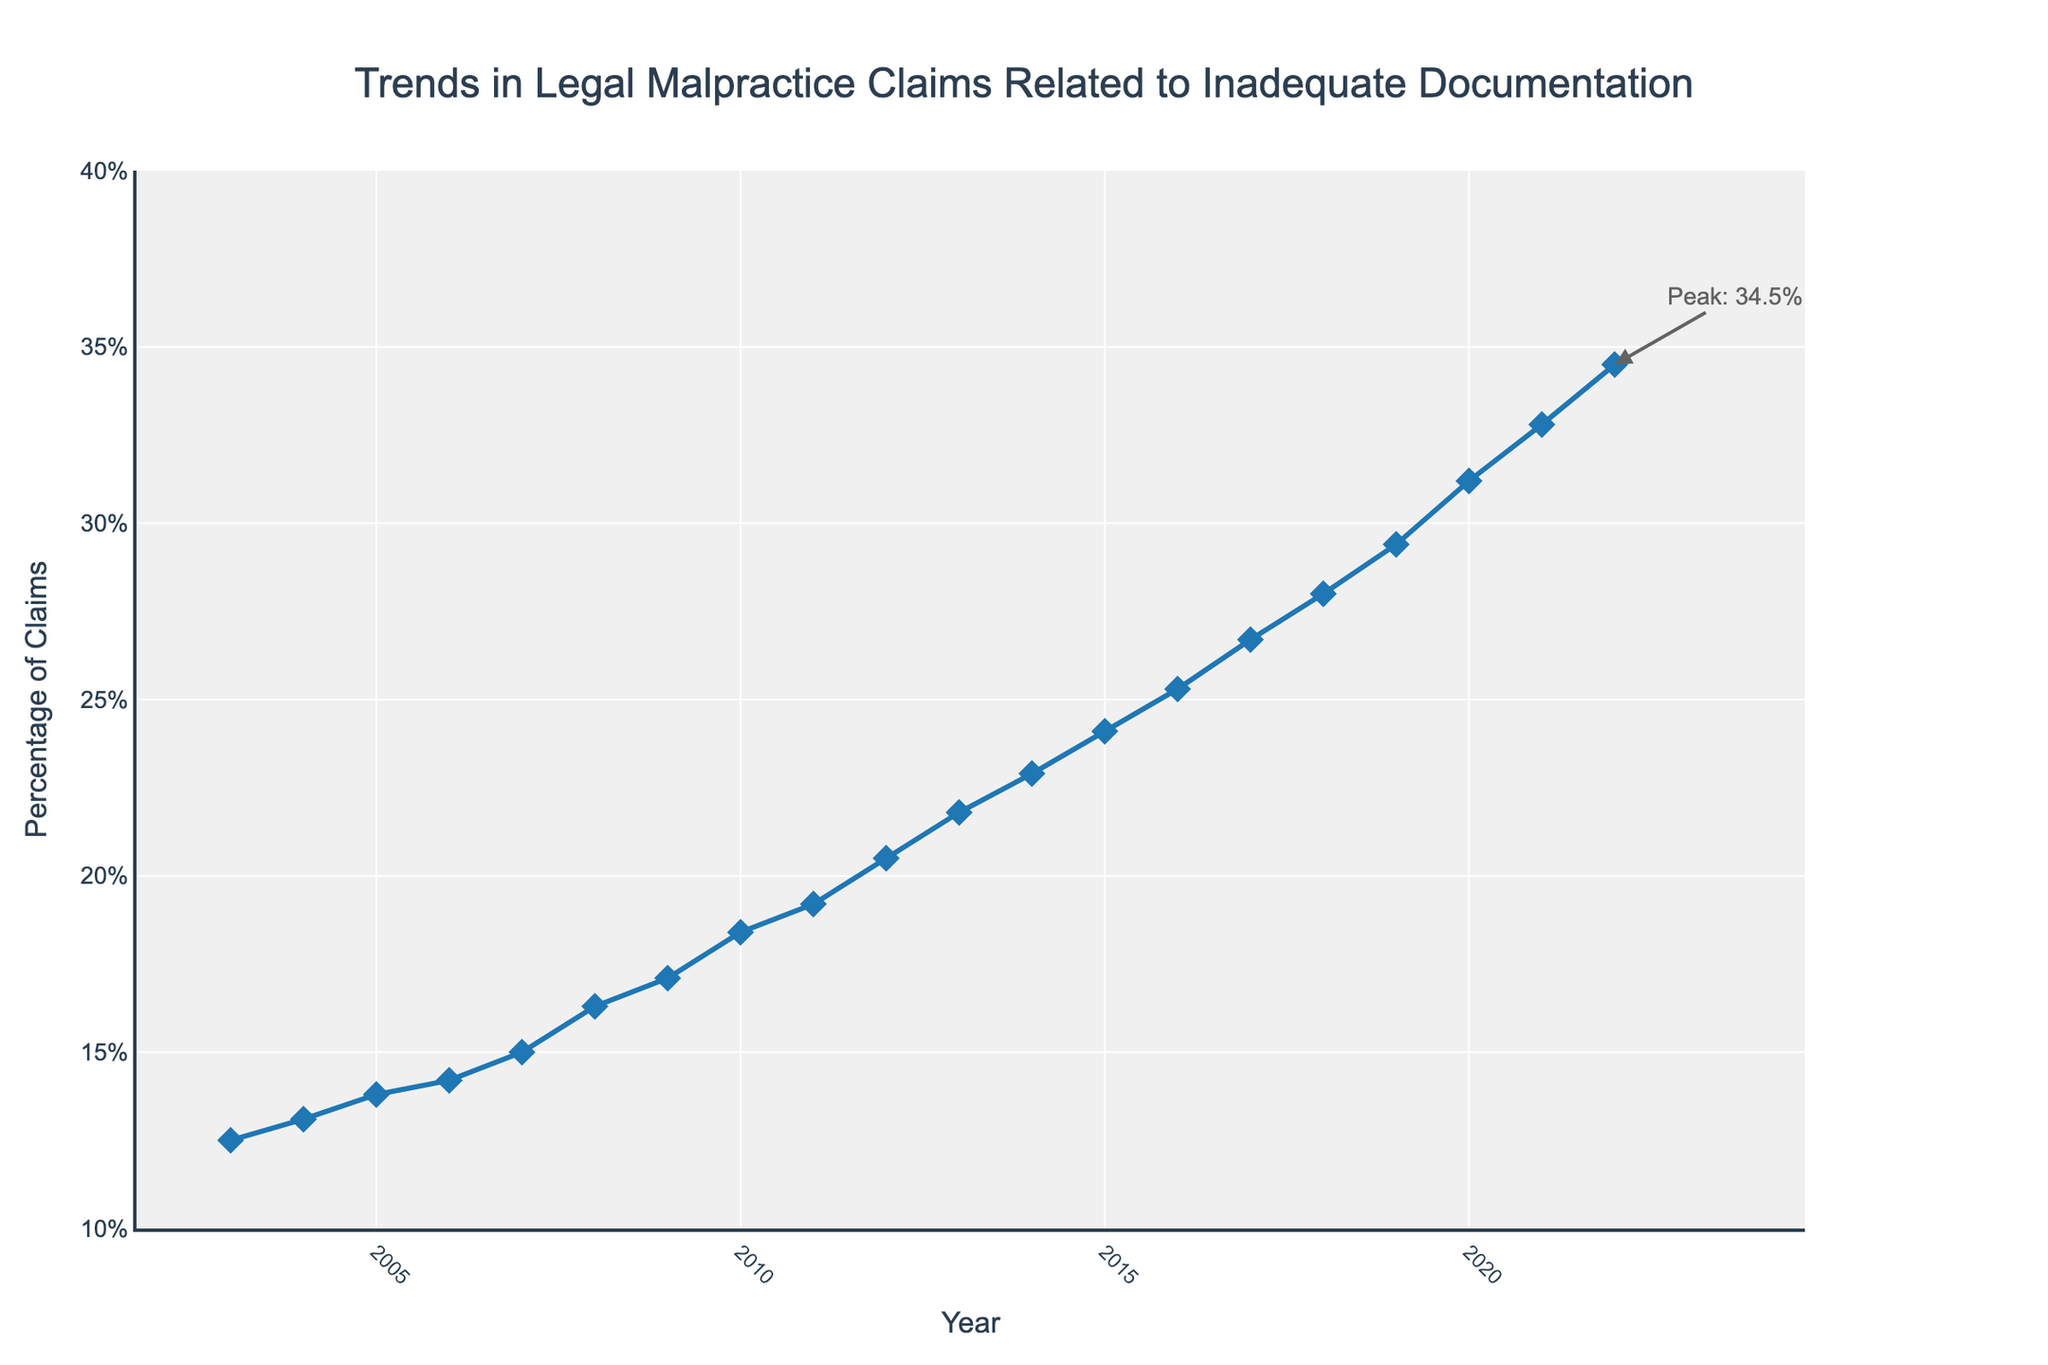What is the overall trend in the percentage of legal malpractice claims related to inadequate documentation over the past 20 years? The overall trend shows a consistent increase in the percentage of claims related to inadequate documentation from 12.5% in 2003 to 34.5% in 2022.
Answer: Consistent increase Which year had the highest percentage of legal malpractice claims related to inadequate documentation? By looking at the endpoint of the line chart and the annotation, it is clear that the year 2022 had the highest percentage of claims at 34.5%.
Answer: 2022 What is the difference in the percentage of claims between the year 2003 and the year 2022? Subtract the percentage of claims in 2003 (12.5%) from the percentage in 2022 (34.5%). The difference is 34.5% - 12.5% = 22%.
Answer: 22% During which year did the percentage of legal malpractice claims exceed 20%? By examining the upward trend in the chart, the percentage exceeded 20% for the first time in the year 2012.
Answer: 2012 What is the average percentage of legal malpractice claims over the 20-year span? Sum the percentages for each year and divide by the number of years. [(12.5 + 13.1 + 13.8 + 14.2 + 15 + 16.3 + 17.1 + 18.4 + 19.2 + 20.5 + 21.8 + 22.9 + 24.1 + 25.3 + 26.7 + 28 + 29.4 + 31.2 + 32.8 + 34.5) ÷ 20 = 21.125]
Answer: 21.13% Between which two consecutive years did the percentage of claims see the smallest increase? Examine the differences in percentages between consecutive years and identify the smallest increase. Between 2003 and 2004, the increase was 13.1% - 12.5% = 0.6%, which is the smallest increment.
Answer: Between 2003 and 2004 Which year had a percentage of legal malpractice claims closest to the average percentage over the 20-year span? The average percentage over 20 years is 21.13%. Comparing each year's percentage to this average, the year 2013 with 21.8% is the closest.
Answer: 2013 By how much did the percentage of claims increase from 2010 to 2022? Subtract the percentage of claims in 2010 (18.4%) from the percentage in 2022 (34.5%). The increase is 34.5% - 18.4% = 16.1%.
Answer: 16.1% Which year experienced the largest annual increase in the percentage of claims? Identify the year with the largest positive difference by calculating the year-over-year increases. The largest increase is from 2019 (29.4%) to 2020 (31.2%), which is 31.2% - 29.4% = 1.8%.
Answer: From 2019 to 2020 What was the percentage of legal malpractice claims in 2015, and how does it compare to the percentage in 2010? The percentage in 2015 was 24.1%, and in 2010 it was 18.4%. The comparison shows an increase of 24.1% - 18.4% = 5.7%.
Answer: 24.1%, increased by 5.7% 